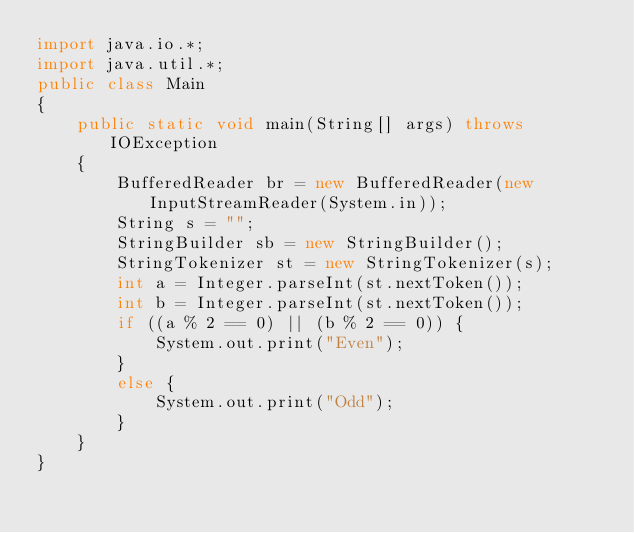<code> <loc_0><loc_0><loc_500><loc_500><_Java_>import java.io.*;
import java.util.*;
public class Main 
{
    public static void main(String[] args) throws IOException 
    {
        BufferedReader br = new BufferedReader(new InputStreamReader(System.in));
        String s = "";
        StringBuilder sb = new StringBuilder();
        StringTokenizer st = new StringTokenizer(s);
        int a = Integer.parseInt(st.nextToken());
        int b = Integer.parseInt(st.nextToken());
        if ((a % 2 == 0) || (b % 2 == 0)) {
            System.out.print("Even");
        }
        else {
            System.out.print("Odd");
        }
    }
}</code> 